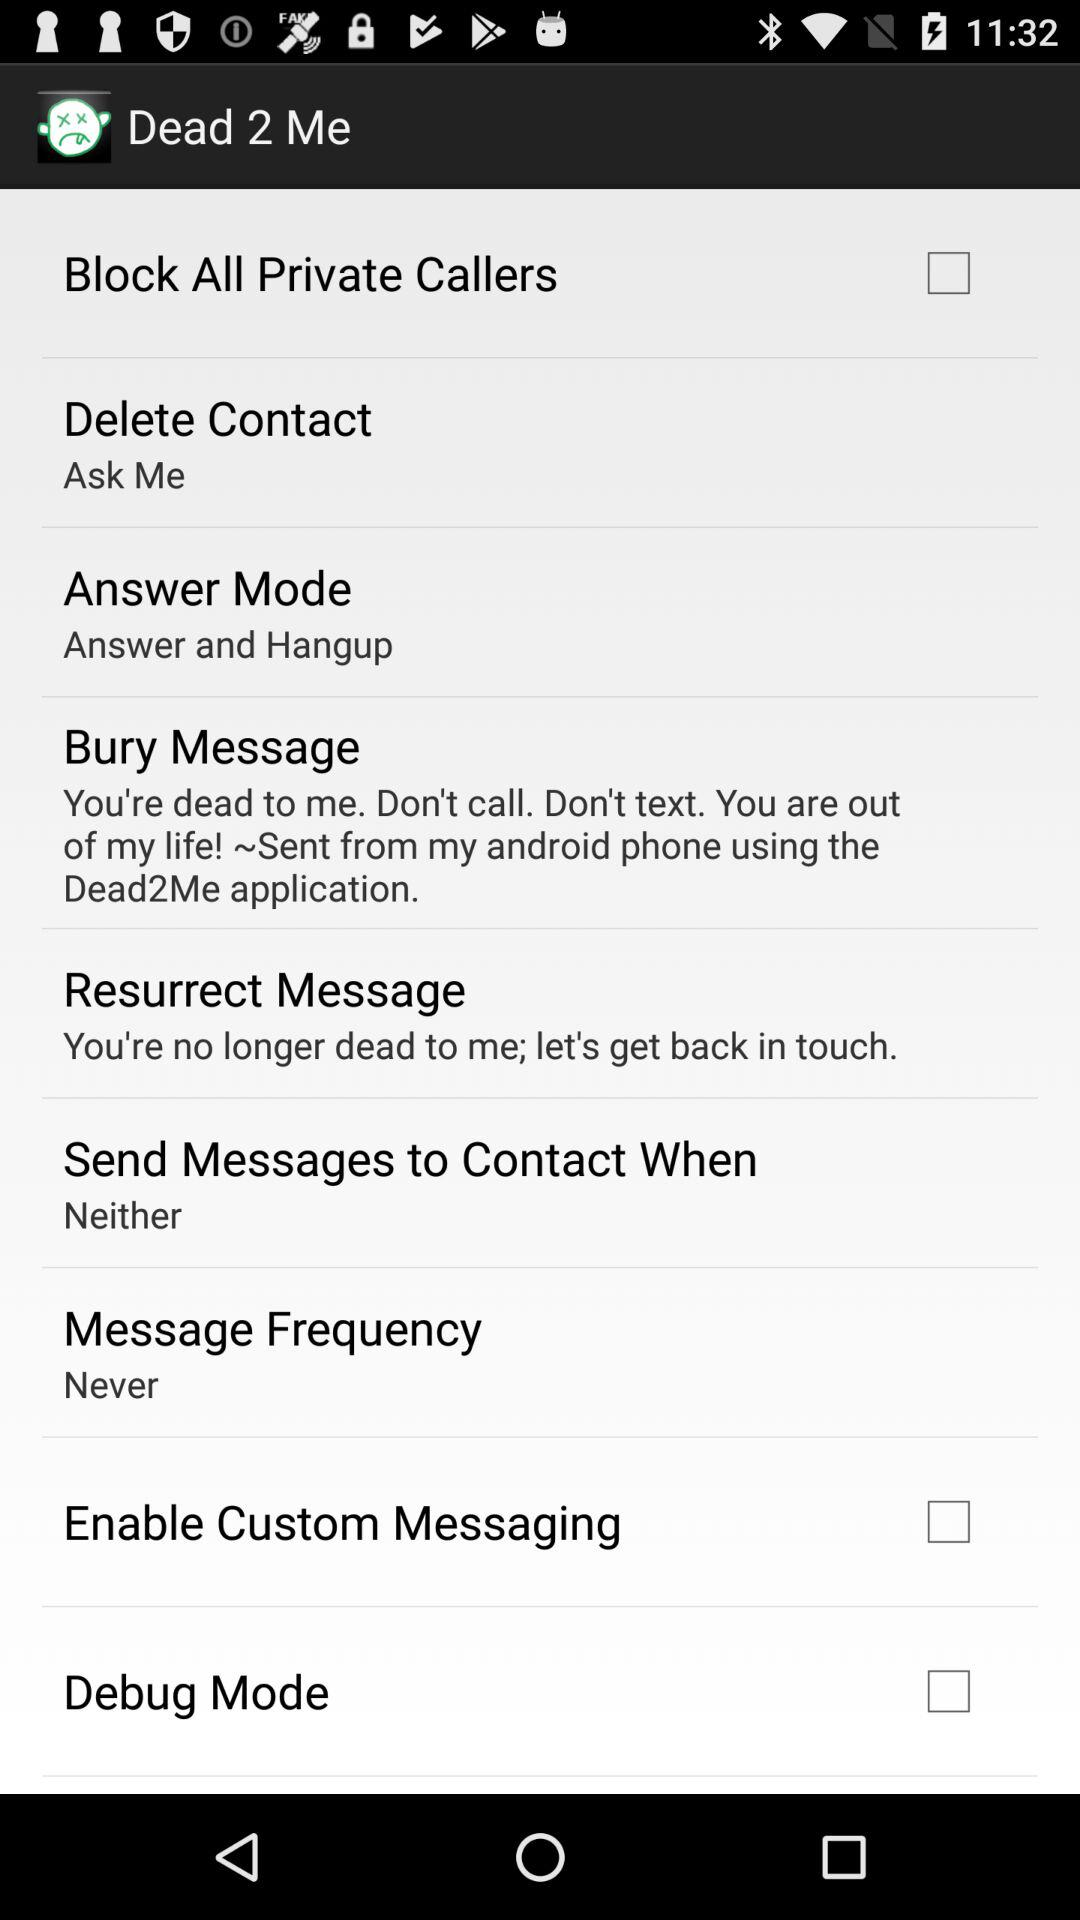What is the status of debug mode? The status is off. 